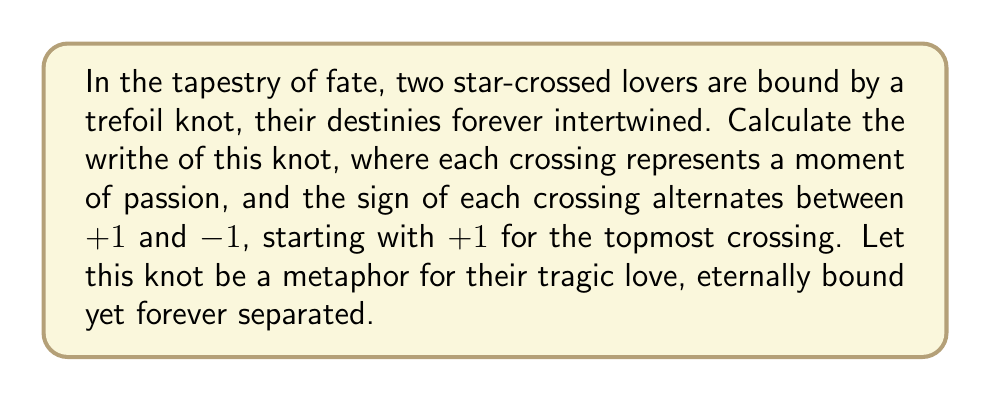Provide a solution to this math problem. To calculate the writhe of the trefoil knot representing our ill-fated lovers, we shall follow these steps:

1) First, recall that the writhe of a knot is the sum of the signs of all crossings in any diagram of the knot.

2) The trefoil knot has three crossings in its standard diagram.

3) We are given that the crossings alternate between +1 and -1, starting with +1 for the topmost crossing.

4) Let us assign the signs to the crossings:
   - Topmost crossing: +1
   - Middle crossing: -1
   - Bottom crossing: +1

5) To calculate the writhe, we sum these signs:

   $$ \text{Writhe} = (+1) + (-1) + (+1) $$

6) Performing the calculation:

   $$ \text{Writhe} = 1 - 1 + 1 = 1 $$

Thus, like the bittersweet nature of their love, the writhe of this knot is a positive unity, symbolizing how their fates, though fraught with conflict, ultimately join in a singular, tragic harmony.
Answer: $1$ 